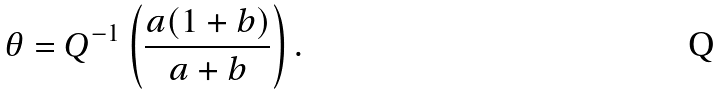<formula> <loc_0><loc_0><loc_500><loc_500>\theta = Q ^ { - 1 } \left ( \frac { a ( 1 + b ) } { a + b } \right ) .</formula> 